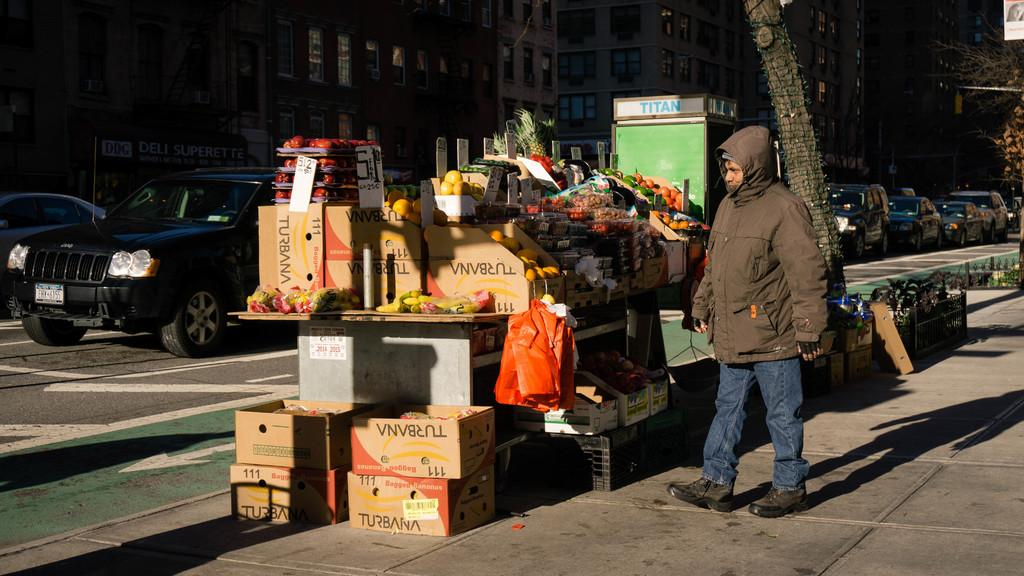What type of vehicles can be seen on the right side of the image? There are cars on the right side of the image. What is the person in the middle of the image doing? A person is walking in the middle of the image. What is the person wearing while walking? The person is wearing a coat. What type of print can be seen on the table in the image? There is no table present in the image, so it is not possible to determine if there is any print on it. What is the person arguing about in the image? There is no argument taking place in the image; the person is simply walking. 